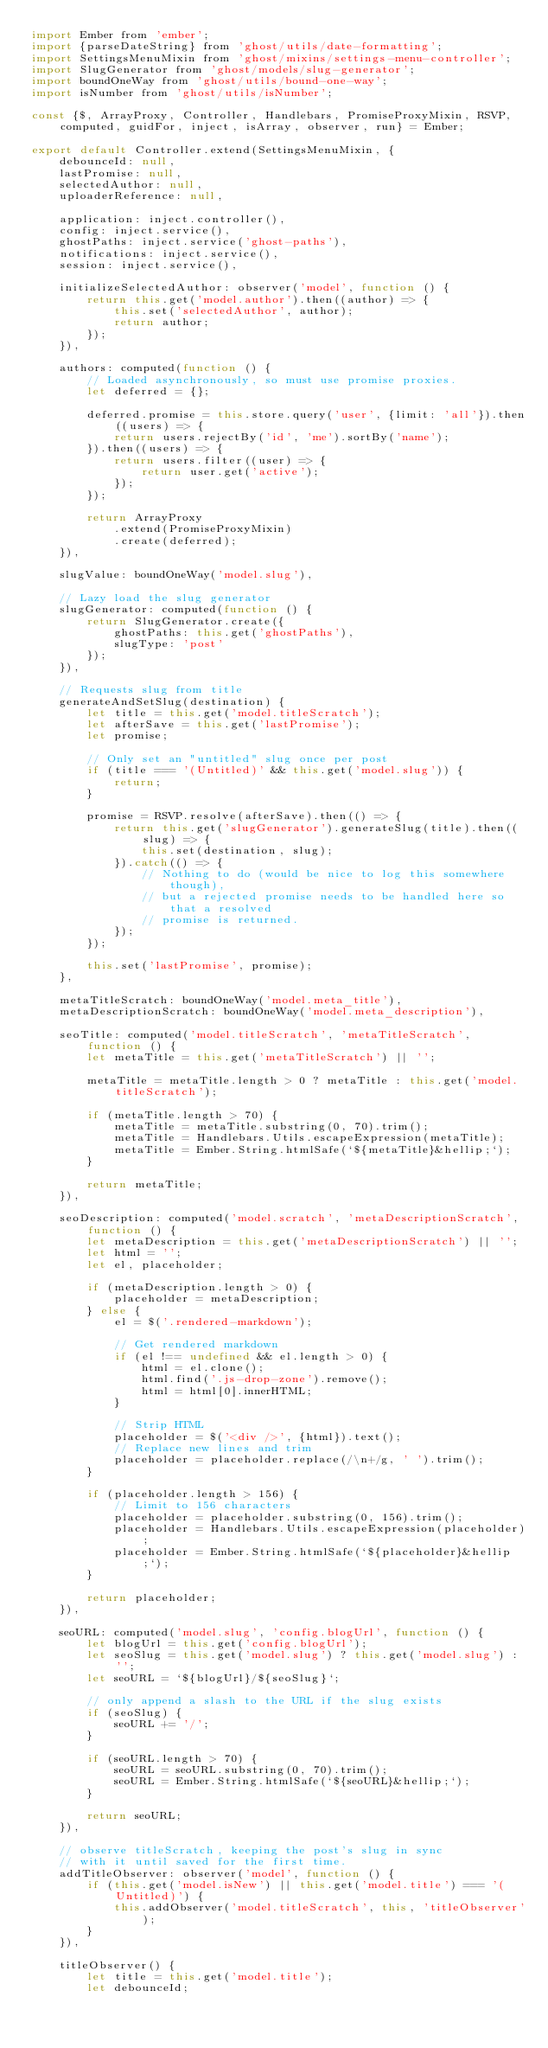Convert code to text. <code><loc_0><loc_0><loc_500><loc_500><_JavaScript_>import Ember from 'ember';
import {parseDateString} from 'ghost/utils/date-formatting';
import SettingsMenuMixin from 'ghost/mixins/settings-menu-controller';
import SlugGenerator from 'ghost/models/slug-generator';
import boundOneWay from 'ghost/utils/bound-one-way';
import isNumber from 'ghost/utils/isNumber';

const {$, ArrayProxy, Controller, Handlebars, PromiseProxyMixin, RSVP, computed, guidFor, inject, isArray, observer, run} = Ember;

export default Controller.extend(SettingsMenuMixin, {
    debounceId: null,
    lastPromise: null,
    selectedAuthor: null,
    uploaderReference: null,

    application: inject.controller(),
    config: inject.service(),
    ghostPaths: inject.service('ghost-paths'),
    notifications: inject.service(),
    session: inject.service(),

    initializeSelectedAuthor: observer('model', function () {
        return this.get('model.author').then((author) => {
            this.set('selectedAuthor', author);
            return author;
        });
    }),

    authors: computed(function () {
        // Loaded asynchronously, so must use promise proxies.
        let deferred = {};

        deferred.promise = this.store.query('user', {limit: 'all'}).then((users) => {
            return users.rejectBy('id', 'me').sortBy('name');
        }).then((users) => {
            return users.filter((user) => {
                return user.get('active');
            });
        });

        return ArrayProxy
            .extend(PromiseProxyMixin)
            .create(deferred);
    }),

    slugValue: boundOneWay('model.slug'),

    // Lazy load the slug generator
    slugGenerator: computed(function () {
        return SlugGenerator.create({
            ghostPaths: this.get('ghostPaths'),
            slugType: 'post'
        });
    }),

    // Requests slug from title
    generateAndSetSlug(destination) {
        let title = this.get('model.titleScratch');
        let afterSave = this.get('lastPromise');
        let promise;

        // Only set an "untitled" slug once per post
        if (title === '(Untitled)' && this.get('model.slug')) {
            return;
        }

        promise = RSVP.resolve(afterSave).then(() => {
            return this.get('slugGenerator').generateSlug(title).then((slug) => {
                this.set(destination, slug);
            }).catch(() => {
                // Nothing to do (would be nice to log this somewhere though),
                // but a rejected promise needs to be handled here so that a resolved
                // promise is returned.
            });
        });

        this.set('lastPromise', promise);
    },

    metaTitleScratch: boundOneWay('model.meta_title'),
    metaDescriptionScratch: boundOneWay('model.meta_description'),

    seoTitle: computed('model.titleScratch', 'metaTitleScratch', function () {
        let metaTitle = this.get('metaTitleScratch') || '';

        metaTitle = metaTitle.length > 0 ? metaTitle : this.get('model.titleScratch');

        if (metaTitle.length > 70) {
            metaTitle = metaTitle.substring(0, 70).trim();
            metaTitle = Handlebars.Utils.escapeExpression(metaTitle);
            metaTitle = Ember.String.htmlSafe(`${metaTitle}&hellip;`);
        }

        return metaTitle;
    }),

    seoDescription: computed('model.scratch', 'metaDescriptionScratch', function () {
        let metaDescription = this.get('metaDescriptionScratch') || '';
        let html = '';
        let el, placeholder;

        if (metaDescription.length > 0) {
            placeholder = metaDescription;
        } else {
            el = $('.rendered-markdown');

            // Get rendered markdown
            if (el !== undefined && el.length > 0) {
                html = el.clone();
                html.find('.js-drop-zone').remove();
                html = html[0].innerHTML;
            }

            // Strip HTML
            placeholder = $('<div />', {html}).text();
            // Replace new lines and trim
            placeholder = placeholder.replace(/\n+/g, ' ').trim();
        }

        if (placeholder.length > 156) {
            // Limit to 156 characters
            placeholder = placeholder.substring(0, 156).trim();
            placeholder = Handlebars.Utils.escapeExpression(placeholder);
            placeholder = Ember.String.htmlSafe(`${placeholder}&hellip;`);
        }

        return placeholder;
    }),

    seoURL: computed('model.slug', 'config.blogUrl', function () {
        let blogUrl = this.get('config.blogUrl');
        let seoSlug = this.get('model.slug') ? this.get('model.slug') : '';
        let seoURL = `${blogUrl}/${seoSlug}`;

        // only append a slash to the URL if the slug exists
        if (seoSlug) {
            seoURL += '/';
        }

        if (seoURL.length > 70) {
            seoURL = seoURL.substring(0, 70).trim();
            seoURL = Ember.String.htmlSafe(`${seoURL}&hellip;`);
        }

        return seoURL;
    }),

    // observe titleScratch, keeping the post's slug in sync
    // with it until saved for the first time.
    addTitleObserver: observer('model', function () {
        if (this.get('model.isNew') || this.get('model.title') === '(Untitled)') {
            this.addObserver('model.titleScratch', this, 'titleObserver');
        }
    }),

    titleObserver() {
        let title = this.get('model.title');
        let debounceId;
</code> 